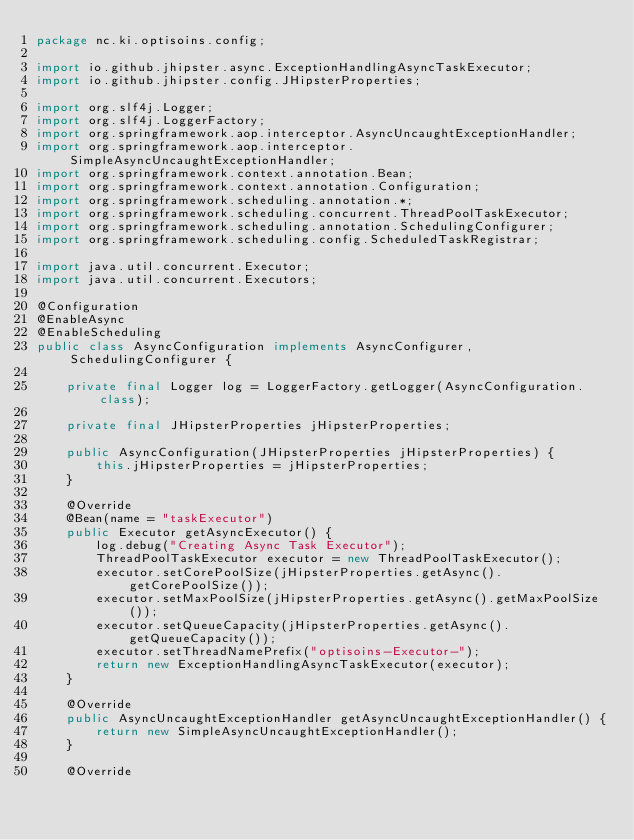<code> <loc_0><loc_0><loc_500><loc_500><_Java_>package nc.ki.optisoins.config;

import io.github.jhipster.async.ExceptionHandlingAsyncTaskExecutor;
import io.github.jhipster.config.JHipsterProperties;

import org.slf4j.Logger;
import org.slf4j.LoggerFactory;
import org.springframework.aop.interceptor.AsyncUncaughtExceptionHandler;
import org.springframework.aop.interceptor.SimpleAsyncUncaughtExceptionHandler;
import org.springframework.context.annotation.Bean;
import org.springframework.context.annotation.Configuration;
import org.springframework.scheduling.annotation.*;
import org.springframework.scheduling.concurrent.ThreadPoolTaskExecutor;
import org.springframework.scheduling.annotation.SchedulingConfigurer;
import org.springframework.scheduling.config.ScheduledTaskRegistrar;

import java.util.concurrent.Executor;
import java.util.concurrent.Executors;

@Configuration
@EnableAsync
@EnableScheduling
public class AsyncConfiguration implements AsyncConfigurer, SchedulingConfigurer {

    private final Logger log = LoggerFactory.getLogger(AsyncConfiguration.class);

    private final JHipsterProperties jHipsterProperties;

    public AsyncConfiguration(JHipsterProperties jHipsterProperties) {
        this.jHipsterProperties = jHipsterProperties;
    }

    @Override
    @Bean(name = "taskExecutor")
    public Executor getAsyncExecutor() {
        log.debug("Creating Async Task Executor");
        ThreadPoolTaskExecutor executor = new ThreadPoolTaskExecutor();
        executor.setCorePoolSize(jHipsterProperties.getAsync().getCorePoolSize());
        executor.setMaxPoolSize(jHipsterProperties.getAsync().getMaxPoolSize());
        executor.setQueueCapacity(jHipsterProperties.getAsync().getQueueCapacity());
        executor.setThreadNamePrefix("optisoins-Executor-");
        return new ExceptionHandlingAsyncTaskExecutor(executor);
    }

    @Override
    public AsyncUncaughtExceptionHandler getAsyncUncaughtExceptionHandler() {
        return new SimpleAsyncUncaughtExceptionHandler();
    }
    
    @Override</code> 